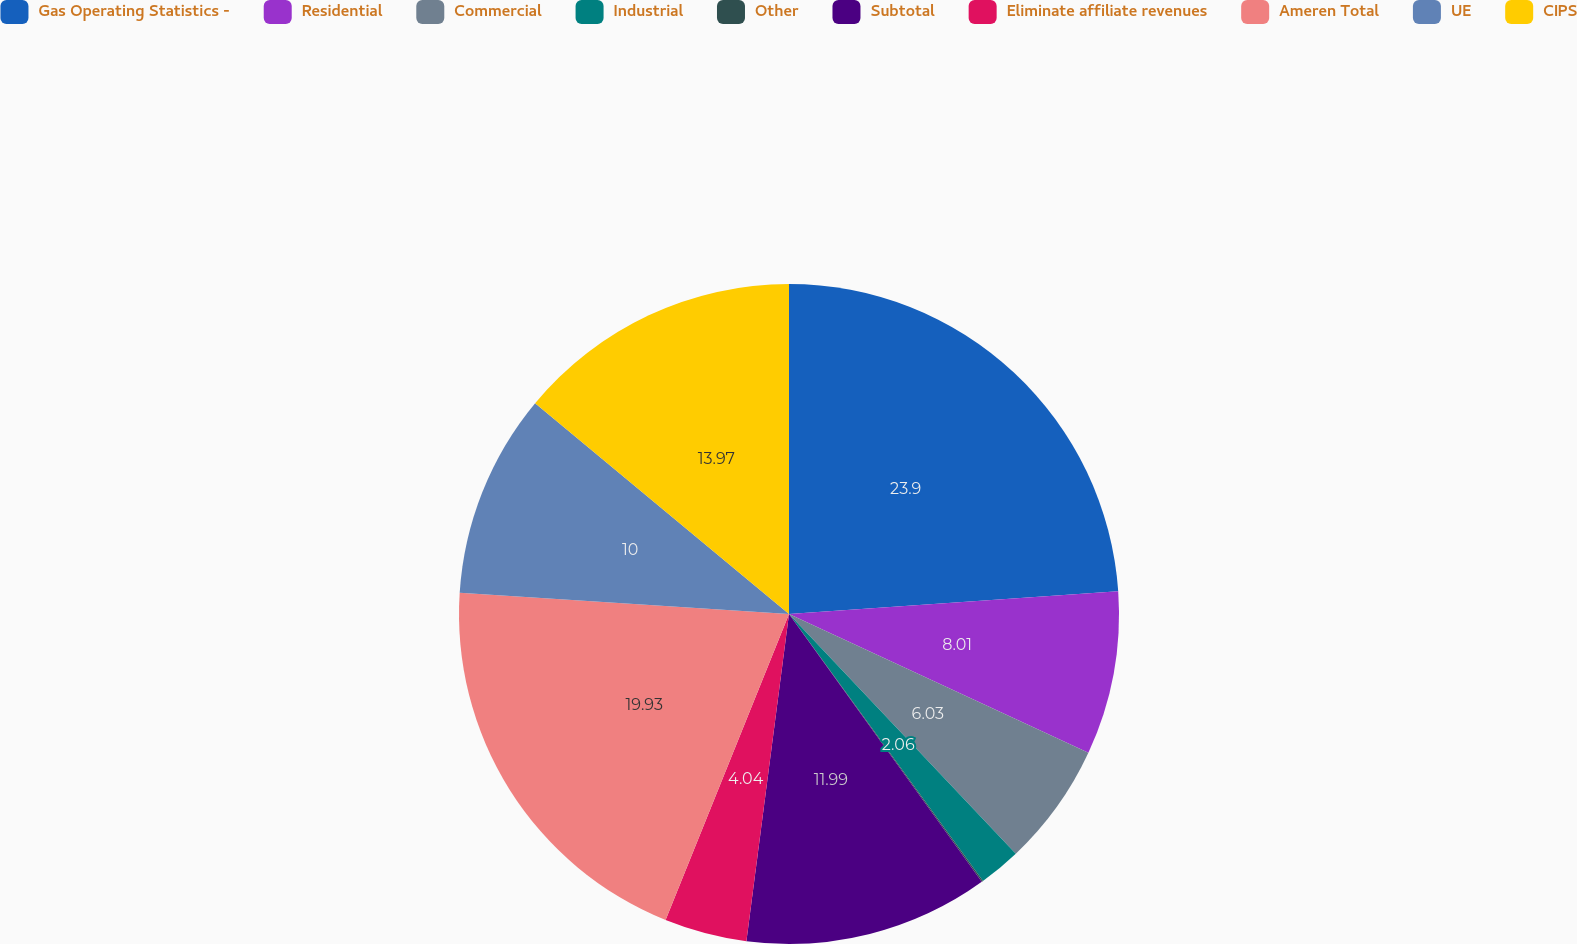Convert chart. <chart><loc_0><loc_0><loc_500><loc_500><pie_chart><fcel>Gas Operating Statistics -<fcel>Residential<fcel>Commercial<fcel>Industrial<fcel>Other<fcel>Subtotal<fcel>Eliminate affiliate revenues<fcel>Ameren Total<fcel>UE<fcel>CIPS<nl><fcel>23.9%<fcel>8.01%<fcel>6.03%<fcel>2.06%<fcel>0.07%<fcel>11.99%<fcel>4.04%<fcel>19.93%<fcel>10.0%<fcel>13.97%<nl></chart> 